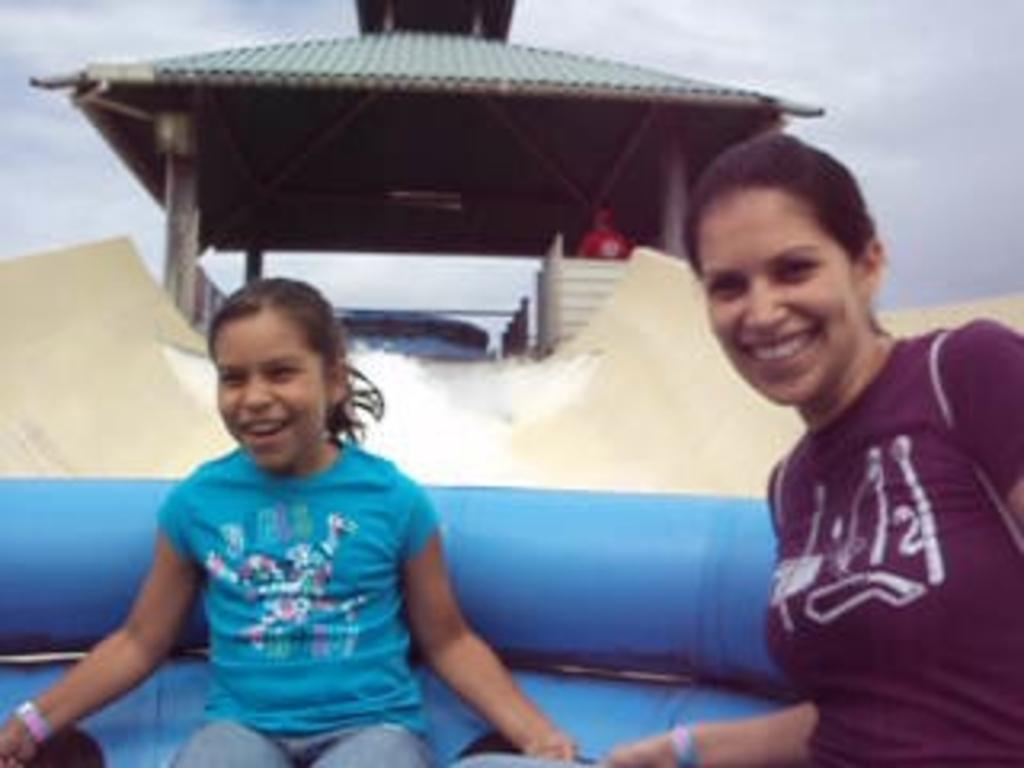How many people are in the image? There are two persons in the image. What are the persons doing in the image? The persons are sitting in an inflatable tube. What is the inflatable tube on? The inflatable tube is on a slider. What can be seen in the water in the image? There is no specific detail about the water in the image, but it is visible. What structure is present in the image? There is a shed in the image. What is visible in the background of the image? The sky is visible in the background of the image. How many pizzas are being served on the button in the image? There are no pizzas or buttons present in the image. What type of mice can be seen playing in the shed in the image? There are no mice present in the image, and the shed is not shown to be a play area for any animals. 